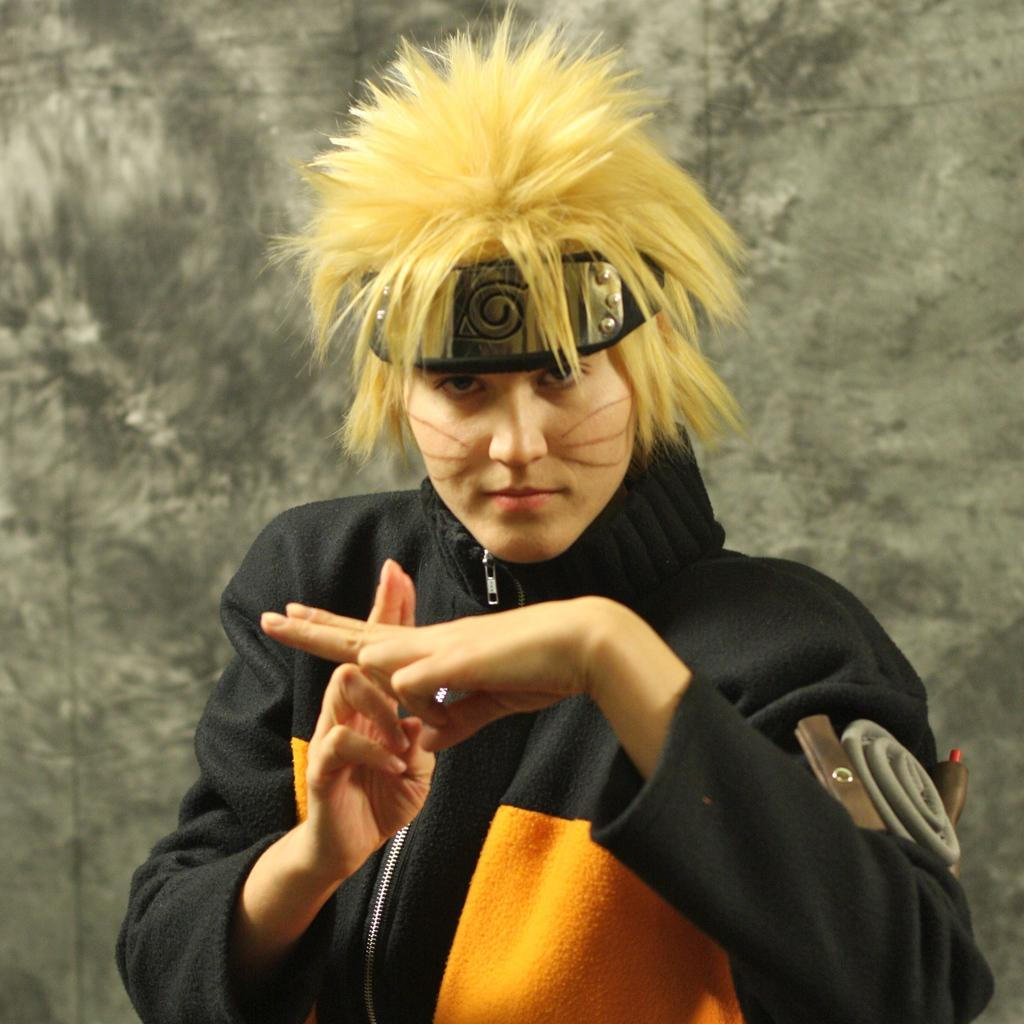Who is the main subject in the foreground of the image? There is a woman in the foreground of the image. What can be seen behind the woman? There is a wall visible behind the woman. Where is the sofa located in the image? There is no sofa present in the image. What type of arch can be seen in the image? There is no arch present in the image. 